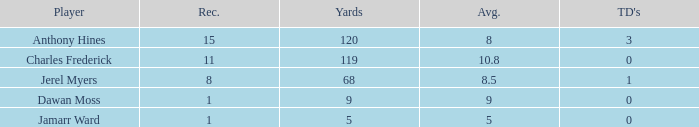What is the highest number of TDs when the Avg is larger than 8.5 and the Rec is less than 1? None. 